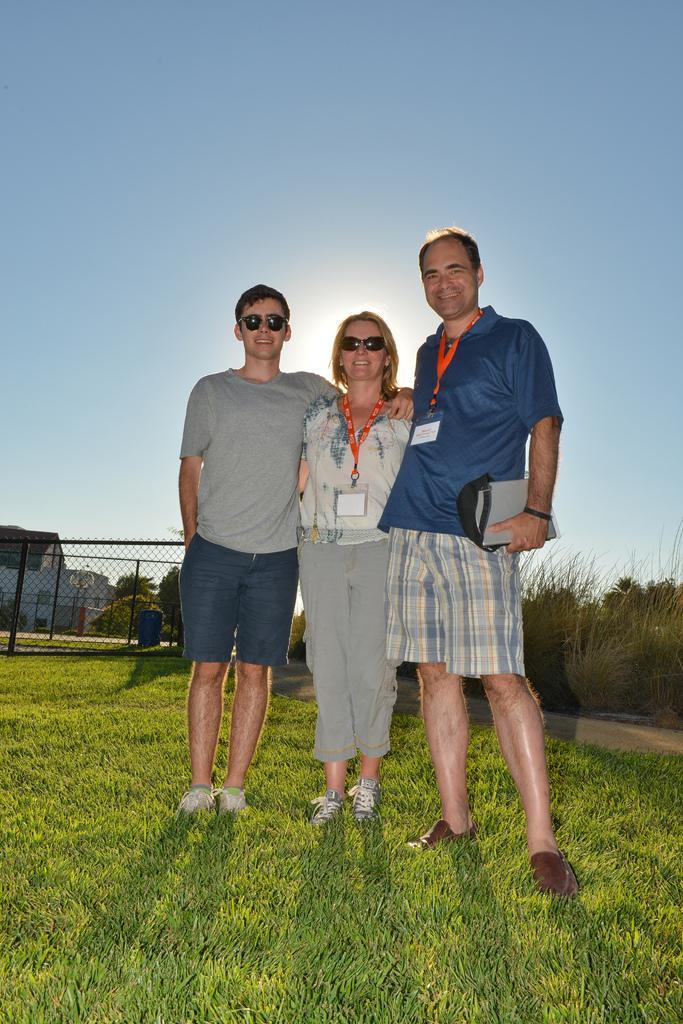How would you summarize this image in a sentence or two? In this image we can see three people standing on the ground holding each other. In that a man is holding a laptop. We can also see some grass and plants. On the backside we can see a metal fence, a drum, trees, a house with roof and the sky which looks cloudy. 